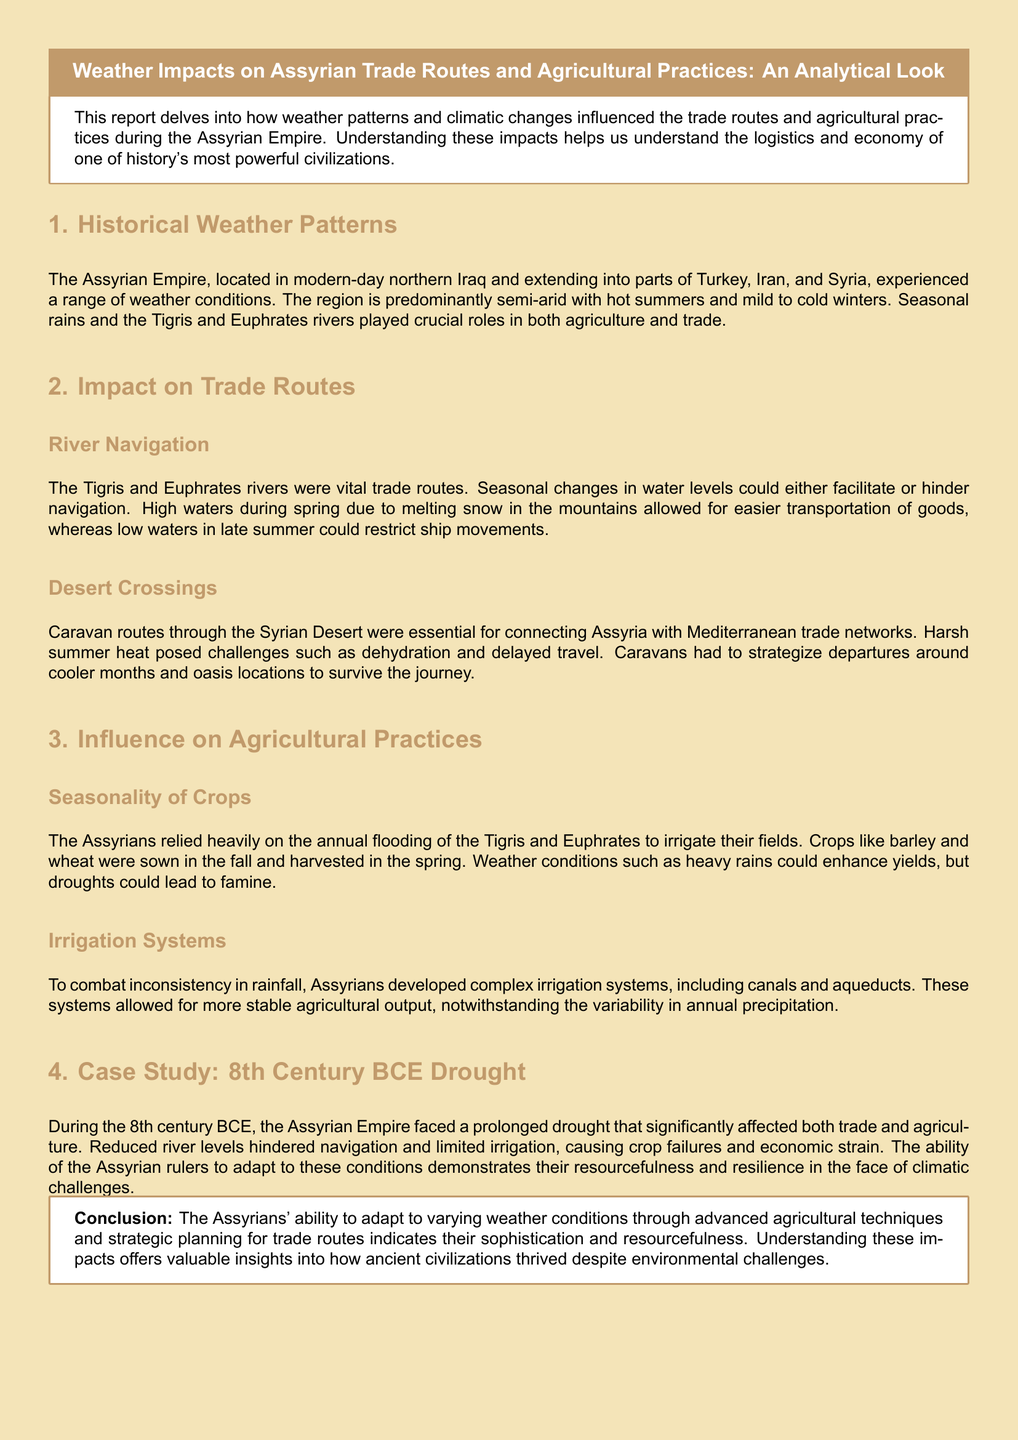What were the main rivers influencing the Assyrian Empire? The Tigris and Euphrates rivers were crucial for agriculture and trade in the Assyrian Empire.
Answer: Tigris and Euphrates What crops did the Assyrians rely on? The Assyrians predominantly cultivated barley and wheat for their agricultural needs.
Answer: Barley and wheat In what century did the Assyrian Empire face a significant drought? The report specifically discusses a prolonged drought that occurred during the 8th century BCE.
Answer: 8th century BCE What seasonal weather condition facilitated river navigation in the spring? Seasonal melting snow in the mountains led to increased water levels that aided transportation.
Answer: High waters What adaptation did the Assyrians develop to manage inconsistent rainfall? The development of complex irrigation systems, including canals and aqueducts, helped stabilize agricultural output.
Answer: Irrigation systems How did harsh summer heat affect desert caravan routes? The extreme heat posed challenges such as dehydration, requiring caravans to adjust their travel plans.
Answer: Dehydration What was the main purpose of the report? The report aims to analyze how weather patterns impacted trade routes and agricultural practices during the Assyrian Empire.
Answer: Analyzing weather impacts on trade and agriculture 